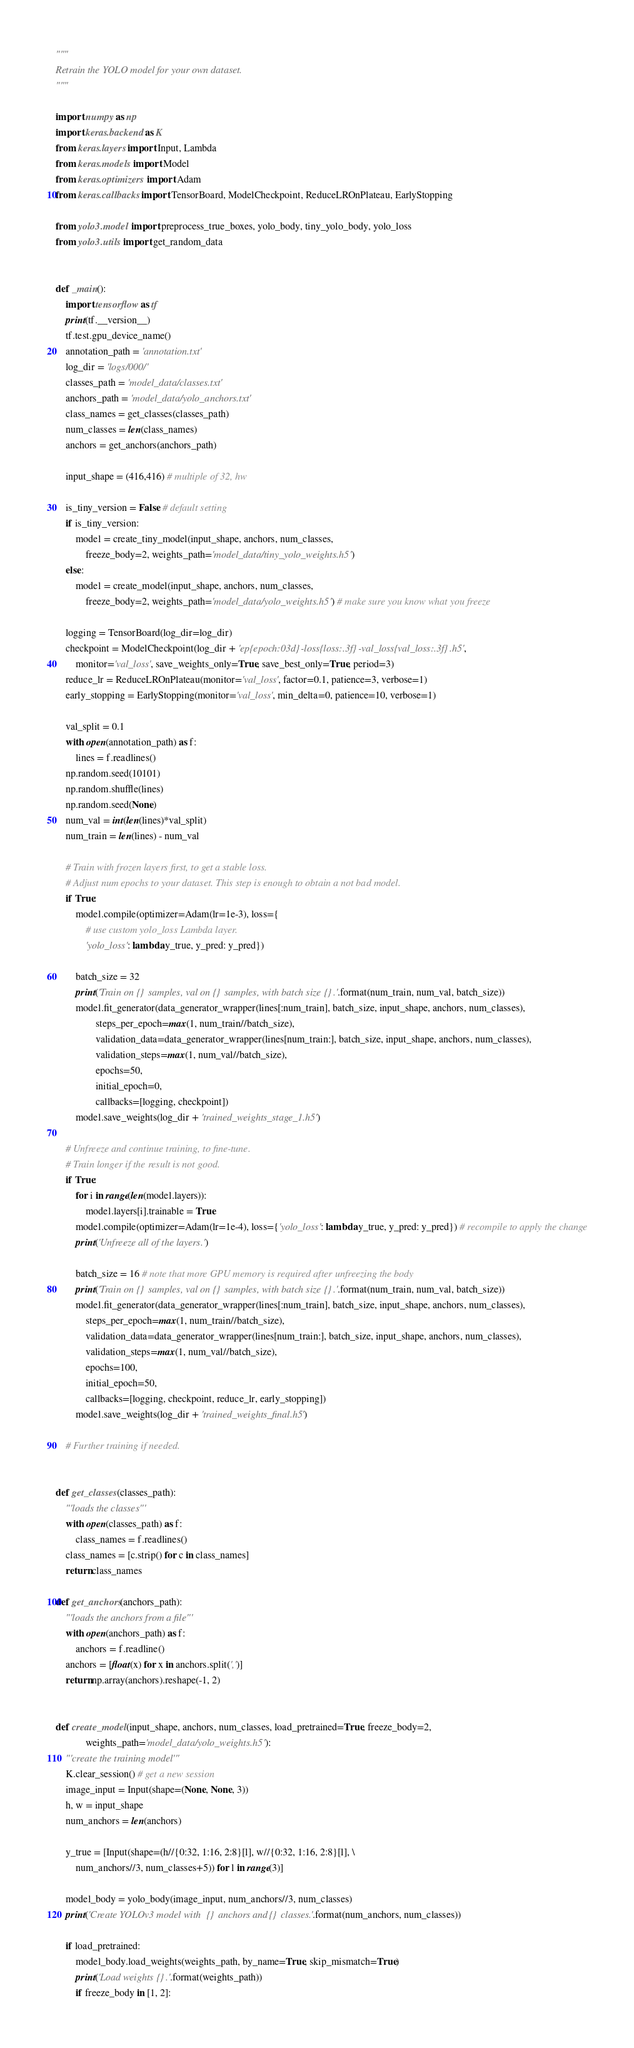<code> <loc_0><loc_0><loc_500><loc_500><_Python_>"""
Retrain the YOLO model for your own dataset.
"""

import numpy as np
import keras.backend as K
from keras.layers import Input, Lambda
from keras.models import Model
from keras.optimizers import Adam
from keras.callbacks import TensorBoard, ModelCheckpoint, ReduceLROnPlateau, EarlyStopping

from yolo3.model import preprocess_true_boxes, yolo_body, tiny_yolo_body, yolo_loss
from yolo3.utils import get_random_data


def _main():
    import tensorflow as tf
    print(tf.__version__)
    tf.test.gpu_device_name()
    annotation_path = 'annotation.txt'
    log_dir = 'logs/000/'
    classes_path = 'model_data/classes.txt'
    anchors_path = 'model_data/yolo_anchors.txt'
    class_names = get_classes(classes_path)
    num_classes = len(class_names)
    anchors = get_anchors(anchors_path)

    input_shape = (416,416) # multiple of 32, hw

    is_tiny_version = False # default setting
    if is_tiny_version:
        model = create_tiny_model(input_shape, anchors, num_classes,
            freeze_body=2, weights_path='model_data/tiny_yolo_weights.h5')
    else:
        model = create_model(input_shape, anchors, num_classes,
            freeze_body=2, weights_path='model_data/yolo_weights.h5') # make sure you know what you freeze

    logging = TensorBoard(log_dir=log_dir)
    checkpoint = ModelCheckpoint(log_dir + 'ep{epoch:03d}-loss{loss:.3f}-val_loss{val_loss:.3f}.h5',
        monitor='val_loss', save_weights_only=True, save_best_only=True, period=3)
    reduce_lr = ReduceLROnPlateau(monitor='val_loss', factor=0.1, patience=3, verbose=1)
    early_stopping = EarlyStopping(monitor='val_loss', min_delta=0, patience=10, verbose=1)

    val_split = 0.1
    with open(annotation_path) as f:
        lines = f.readlines()
    np.random.seed(10101)
    np.random.shuffle(lines)
    np.random.seed(None)
    num_val = int(len(lines)*val_split)
    num_train = len(lines) - num_val

    # Train with frozen layers first, to get a stable loss.
    # Adjust num epochs to your dataset. This step is enough to obtain a not bad model.
    if True:
        model.compile(optimizer=Adam(lr=1e-3), loss={
            # use custom yolo_loss Lambda layer.
            'yolo_loss': lambda y_true, y_pred: y_pred})

        batch_size = 32
        print('Train on {} samples, val on {} samples, with batch size {}.'.format(num_train, num_val, batch_size))
        model.fit_generator(data_generator_wrapper(lines[:num_train], batch_size, input_shape, anchors, num_classes),
                steps_per_epoch=max(1, num_train//batch_size),
                validation_data=data_generator_wrapper(lines[num_train:], batch_size, input_shape, anchors, num_classes),
                validation_steps=max(1, num_val//batch_size),
                epochs=50,
                initial_epoch=0,
                callbacks=[logging, checkpoint])
        model.save_weights(log_dir + 'trained_weights_stage_1.h5')

    # Unfreeze and continue training, to fine-tune.
    # Train longer if the result is not good.
    if True:
        for i in range(len(model.layers)):
            model.layers[i].trainable = True
        model.compile(optimizer=Adam(lr=1e-4), loss={'yolo_loss': lambda y_true, y_pred: y_pred}) # recompile to apply the change
        print('Unfreeze all of the layers.')

        batch_size = 16 # note that more GPU memory is required after unfreezing the body
        print('Train on {} samples, val on {} samples, with batch size {}.'.format(num_train, num_val, batch_size))
        model.fit_generator(data_generator_wrapper(lines[:num_train], batch_size, input_shape, anchors, num_classes),
            steps_per_epoch=max(1, num_train//batch_size),
            validation_data=data_generator_wrapper(lines[num_train:], batch_size, input_shape, anchors, num_classes),
            validation_steps=max(1, num_val//batch_size),
            epochs=100,
            initial_epoch=50,
            callbacks=[logging, checkpoint, reduce_lr, early_stopping])
        model.save_weights(log_dir + 'trained_weights_final.h5')

    # Further training if needed.


def get_classes(classes_path):
    '''loads the classes'''
    with open(classes_path) as f:
        class_names = f.readlines()
    class_names = [c.strip() for c in class_names]
    return class_names

def get_anchors(anchors_path):
    '''loads the anchors from a file'''
    with open(anchors_path) as f:
        anchors = f.readline()
    anchors = [float(x) for x in anchors.split(',')]
    return np.array(anchors).reshape(-1, 2)


def create_model(input_shape, anchors, num_classes, load_pretrained=True, freeze_body=2,
            weights_path='model_data/yolo_weights.h5'):
    '''create the training model'''
    K.clear_session() # get a new session
    image_input = Input(shape=(None, None, 3))
    h, w = input_shape
    num_anchors = len(anchors)

    y_true = [Input(shape=(h//{0:32, 1:16, 2:8}[l], w//{0:32, 1:16, 2:8}[l], \
        num_anchors//3, num_classes+5)) for l in range(3)]

    model_body = yolo_body(image_input, num_anchors//3, num_classes)
    print('Create YOLOv3 model with {} anchors and {} classes.'.format(num_anchors, num_classes))

    if load_pretrained:
        model_body.load_weights(weights_path, by_name=True, skip_mismatch=True)
        print('Load weights {}.'.format(weights_path))
        if freeze_body in [1, 2]:</code> 